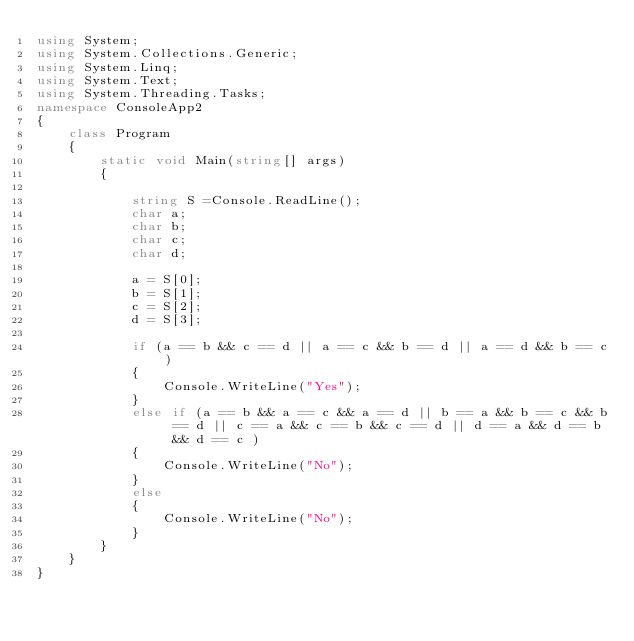Convert code to text. <code><loc_0><loc_0><loc_500><loc_500><_C#_>using System;
using System.Collections.Generic;
using System.Linq;
using System.Text;
using System.Threading.Tasks;
namespace ConsoleApp2
{
    class Program
    {
        static void Main(string[] args)
        {

            string S =Console.ReadLine();
            char a;
            char b;
            char c;
            char d;

            a = S[0];
            b = S[1];
            c = S[2];
            d = S[3];

            if (a == b && c == d || a == c && b == d || a == d && b == c)
            {
                Console.WriteLine("Yes");
            }
            else if (a == b && a == c && a == d || b == a && b == c && b == d || c == a && c == b && c == d || d == a && d == b && d == c )
            {
                Console.WriteLine("No");
            }
            else
            {
                Console.WriteLine("No");
            }
        }
    }
}
</code> 